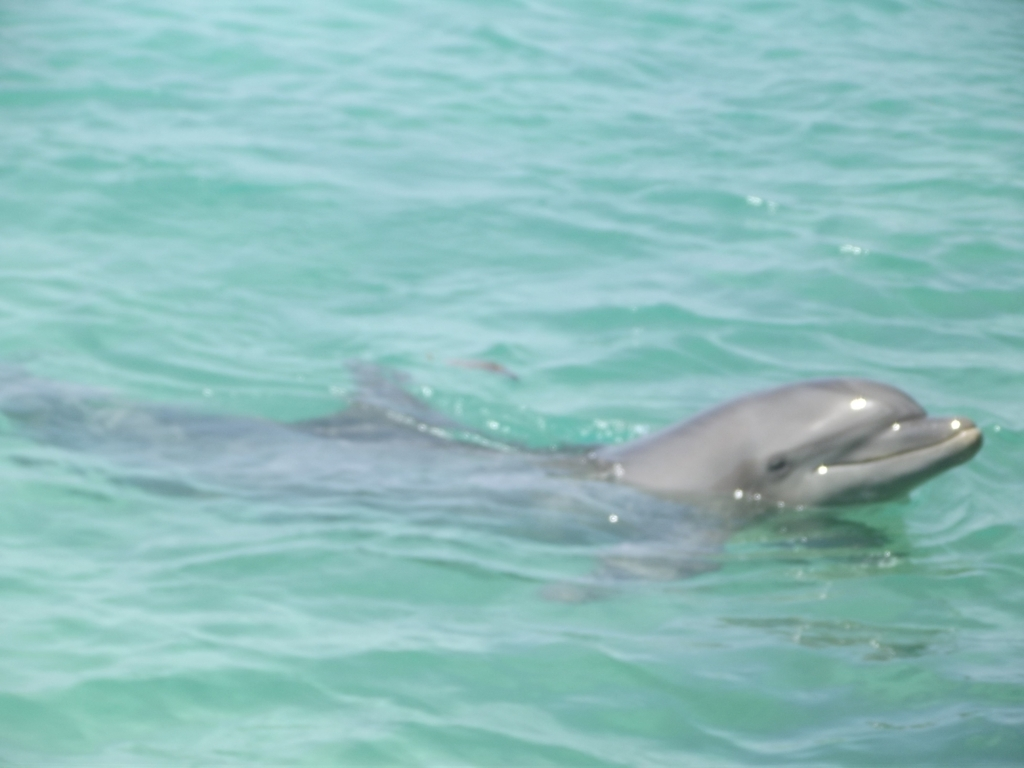What can you tell me about the habitat of dolphins? Dolphins are highly adaptable and live in a variety of marine environments around the world. They are commonly found in shallow, warmer waters of the continental shelves, which can be seen hinted at by the clear, tropical waters in the image. 